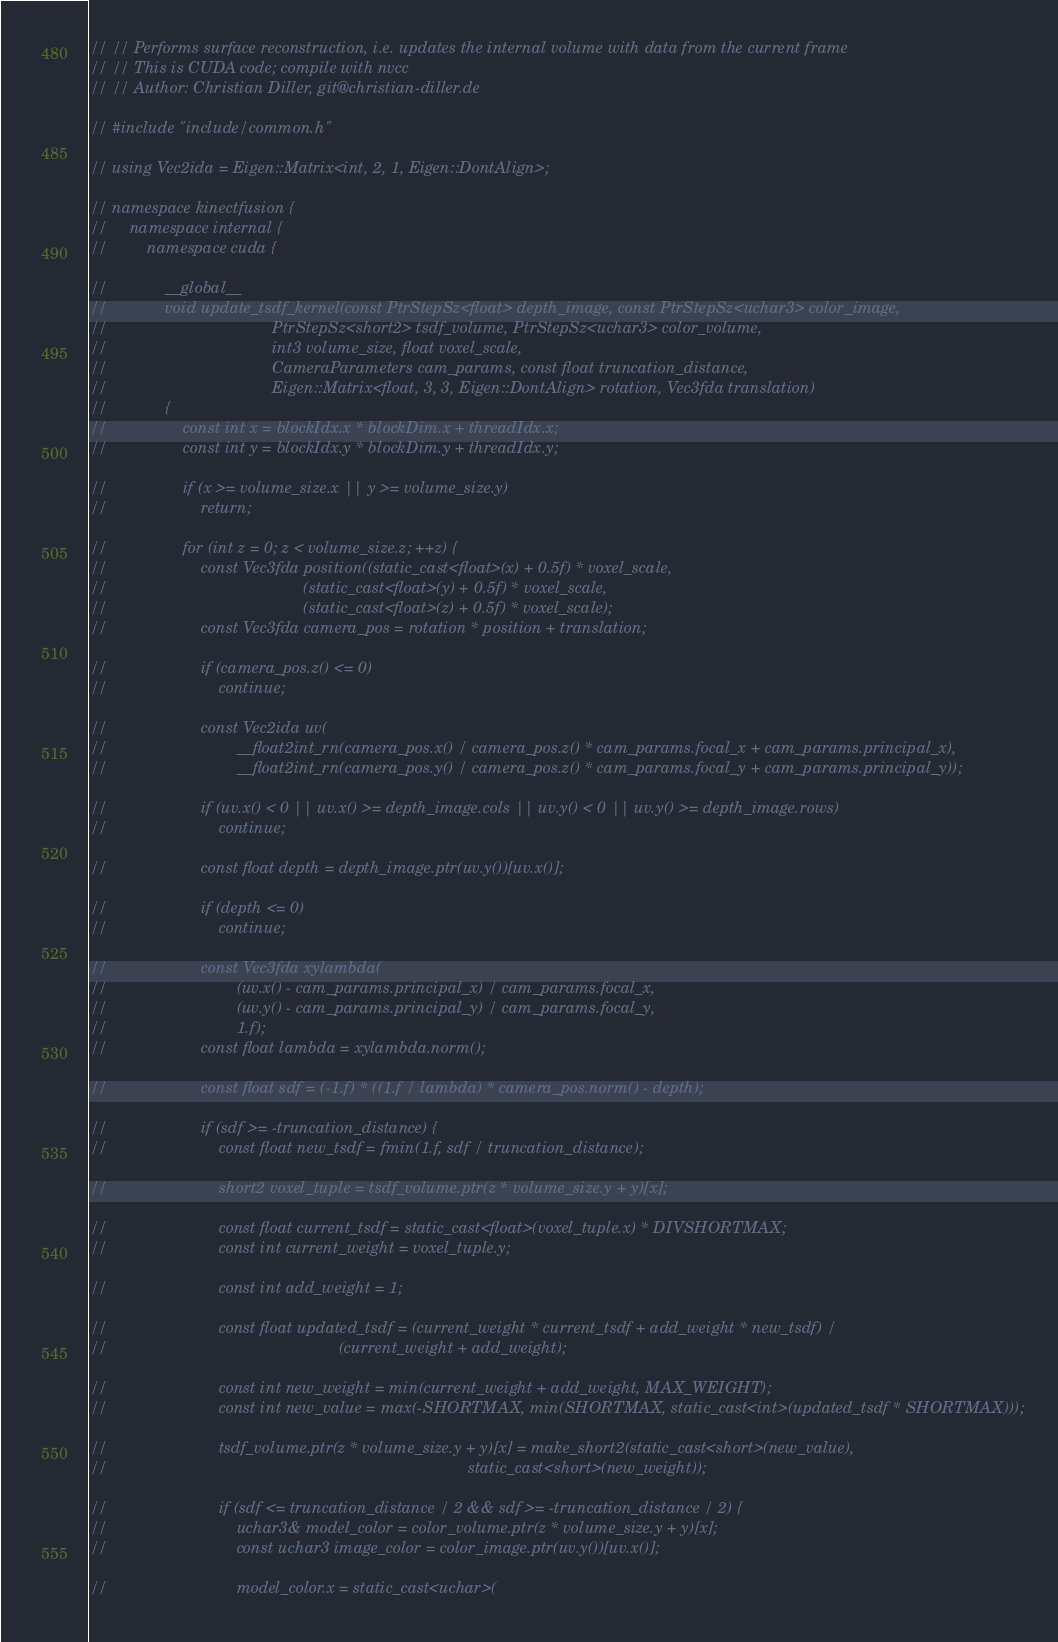<code> <loc_0><loc_0><loc_500><loc_500><_Cuda_>// // Performs surface reconstruction, i.e. updates the internal volume with data from the current frame
// // This is CUDA code; compile with nvcc
// // Author: Christian Diller, git@christian-diller.de

// #include "include/common.h"

// using Vec2ida = Eigen::Matrix<int, 2, 1, Eigen::DontAlign>;

// namespace kinectfusion {
//     namespace internal {
//         namespace cuda {

//             __global__
//             void update_tsdf_kernel(const PtrStepSz<float> depth_image, const PtrStepSz<uchar3> color_image,
//                                     PtrStepSz<short2> tsdf_volume, PtrStepSz<uchar3> color_volume,
//                                     int3 volume_size, float voxel_scale,
//                                     CameraParameters cam_params, const float truncation_distance,
//                                     Eigen::Matrix<float, 3, 3, Eigen::DontAlign> rotation, Vec3fda translation)
//             {
//                 const int x = blockIdx.x * blockDim.x + threadIdx.x;
//                 const int y = blockIdx.y * blockDim.y + threadIdx.y;

//                 if (x >= volume_size.x || y >= volume_size.y)
//                     return;

//                 for (int z = 0; z < volume_size.z; ++z) {
//                     const Vec3fda position((static_cast<float>(x) + 0.5f) * voxel_scale,
//                                            (static_cast<float>(y) + 0.5f) * voxel_scale,
//                                            (static_cast<float>(z) + 0.5f) * voxel_scale);
//                     const Vec3fda camera_pos = rotation * position + translation;

//                     if (camera_pos.z() <= 0)
//                         continue;

//                     const Vec2ida uv(
//                             __float2int_rn(camera_pos.x() / camera_pos.z() * cam_params.focal_x + cam_params.principal_x),
//                             __float2int_rn(camera_pos.y() / camera_pos.z() * cam_params.focal_y + cam_params.principal_y));

//                     if (uv.x() < 0 || uv.x() >= depth_image.cols || uv.y() < 0 || uv.y() >= depth_image.rows)
//                         continue;

//                     const float depth = depth_image.ptr(uv.y())[uv.x()];

//                     if (depth <= 0)
//                         continue;

//                     const Vec3fda xylambda(
//                             (uv.x() - cam_params.principal_x) / cam_params.focal_x,
//                             (uv.y() - cam_params.principal_y) / cam_params.focal_y,
//                             1.f);
//                     const float lambda = xylambda.norm();

//                     const float sdf = (-1.f) * ((1.f / lambda) * camera_pos.norm() - depth);

//                     if (sdf >= -truncation_distance) {
//                         const float new_tsdf = fmin(1.f, sdf / truncation_distance);

//                         short2 voxel_tuple = tsdf_volume.ptr(z * volume_size.y + y)[x];

//                         const float current_tsdf = static_cast<float>(voxel_tuple.x) * DIVSHORTMAX;
//                         const int current_weight = voxel_tuple.y;

//                         const int add_weight = 1;

//                         const float updated_tsdf = (current_weight * current_tsdf + add_weight * new_tsdf) /
//                                                    (current_weight + add_weight);

//                         const int new_weight = min(current_weight + add_weight, MAX_WEIGHT);
//                         const int new_value = max(-SHORTMAX, min(SHORTMAX, static_cast<int>(updated_tsdf * SHORTMAX)));

//                         tsdf_volume.ptr(z * volume_size.y + y)[x] = make_short2(static_cast<short>(new_value),
//                                                                                 static_cast<short>(new_weight));

//                         if (sdf <= truncation_distance / 2 && sdf >= -truncation_distance / 2) {
//                             uchar3& model_color = color_volume.ptr(z * volume_size.y + y)[x];
//                             const uchar3 image_color = color_image.ptr(uv.y())[uv.x()];

//                             model_color.x = static_cast<uchar>(</code> 